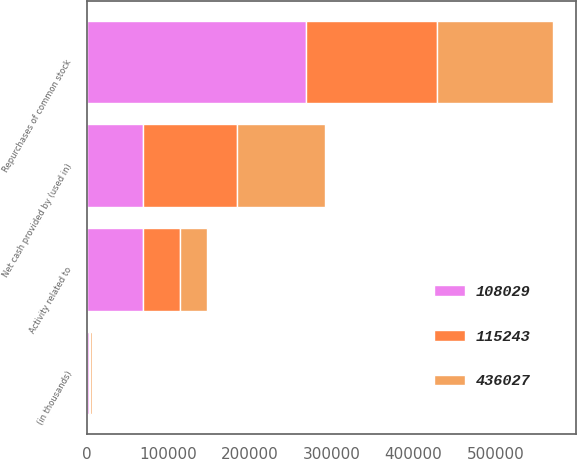Convert chart to OTSL. <chart><loc_0><loc_0><loc_500><loc_500><stacked_bar_chart><ecel><fcel>(in thousands)<fcel>Activity related to<fcel>Repurchases of common stock<fcel>Net cash provided by (used in)<nl><fcel>108029<fcel>2014<fcel>68698<fcel>268647<fcel>68698<nl><fcel>115243<fcel>2013<fcel>45176<fcel>160419<fcel>115243<nl><fcel>436027<fcel>2012<fcel>33439<fcel>141468<fcel>108029<nl></chart> 